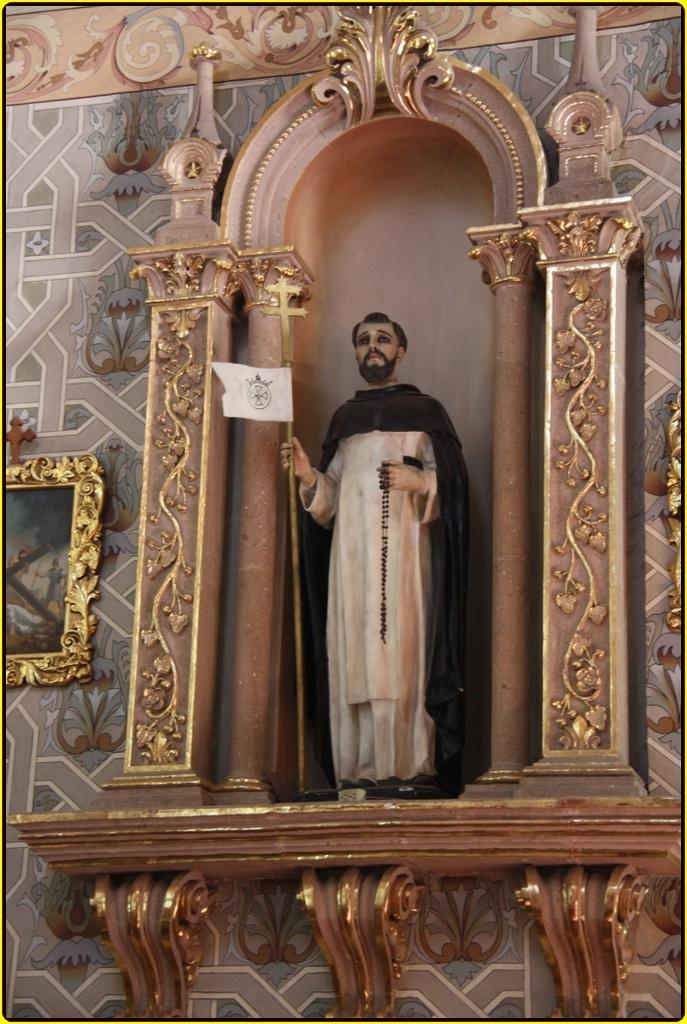What is the main subject of the image? There is a person statue in the image. What is the person statue holding? The person statue is holding something. What can be seen on the wall in the image? There are frames attached to a colorful wall in the image. What type of account does the person statue have with the coat in the image? There is no coat present in the image, and the person statue is a statue, so it cannot have an account. 